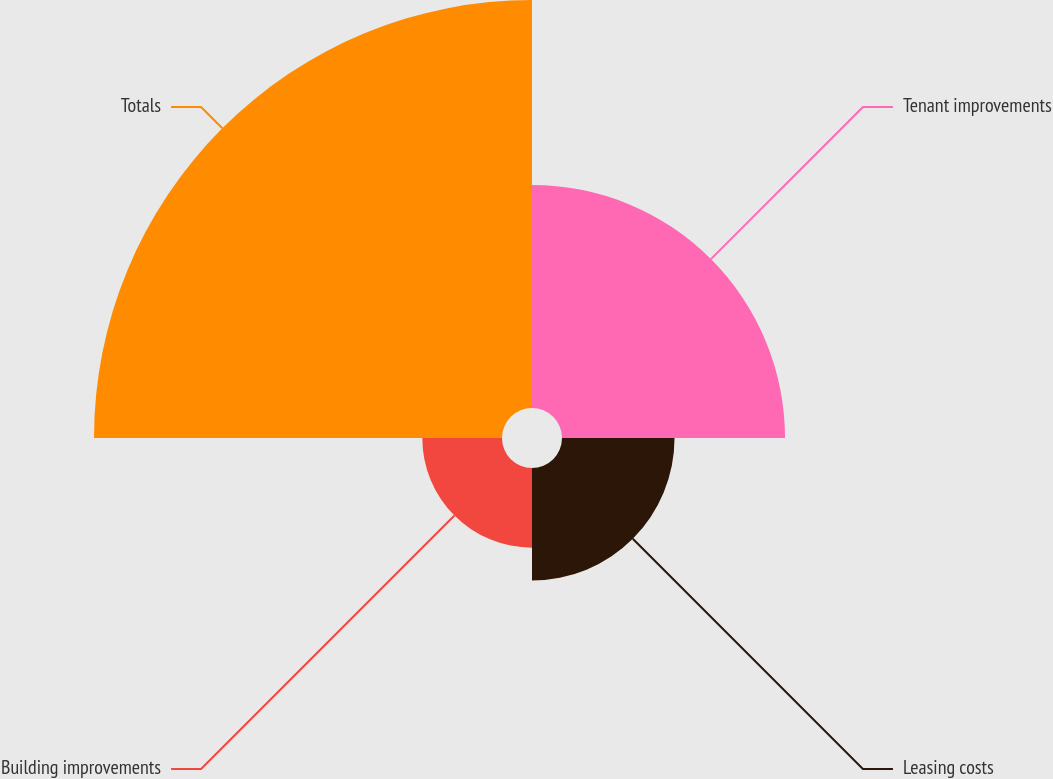<chart> <loc_0><loc_0><loc_500><loc_500><pie_chart><fcel>Tenant improvements<fcel>Leasing costs<fcel>Building improvements<fcel>Totals<nl><fcel>27.09%<fcel>13.67%<fcel>9.68%<fcel>49.56%<nl></chart> 